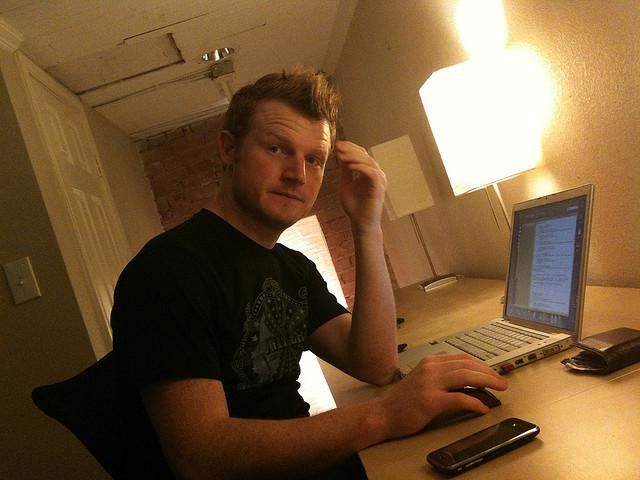Is there a design on his shirt?
Be succinct. Yes. How many lamps are in the picture?
Quick response, please. 2. What is on the computer screen?
Be succinct. Document. 